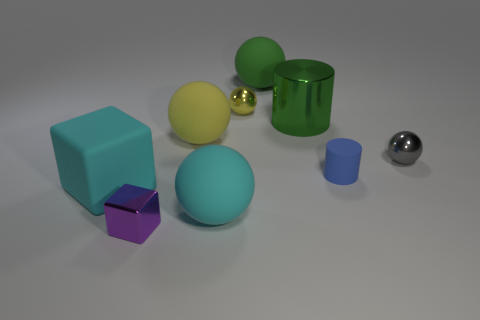Add 1 big yellow matte spheres. How many objects exist? 10 Subtract all large green rubber balls. How many balls are left? 4 Subtract all blue cylinders. How many cylinders are left? 1 Subtract 1 cylinders. How many cylinders are left? 1 Subtract all blocks. How many objects are left? 7 Subtract all gray balls. Subtract all brown cylinders. How many balls are left? 4 Subtract all cyan spheres. How many purple cubes are left? 1 Subtract all matte balls. Subtract all purple metal blocks. How many objects are left? 5 Add 2 large yellow rubber spheres. How many large yellow rubber spheres are left? 3 Add 2 small purple metallic things. How many small purple metallic things exist? 3 